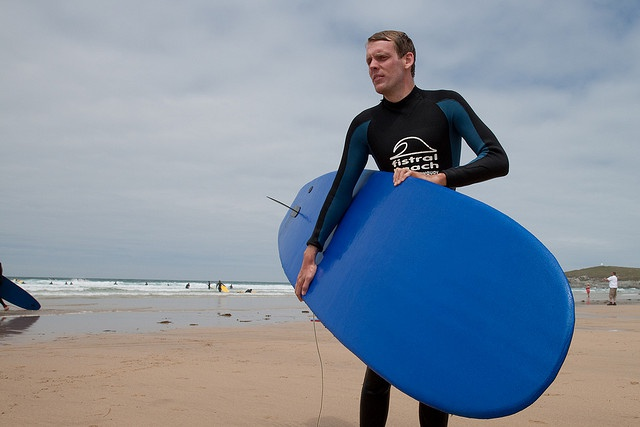Describe the objects in this image and their specific colors. I can see surfboard in darkgray, blue, navy, gray, and darkblue tones, people in darkgray, black, brown, and navy tones, surfboard in darkgray, black, navy, and gray tones, people in darkgray, lightgray, gray, and lightblue tones, and people in darkgray, gray, and lightgray tones in this image. 